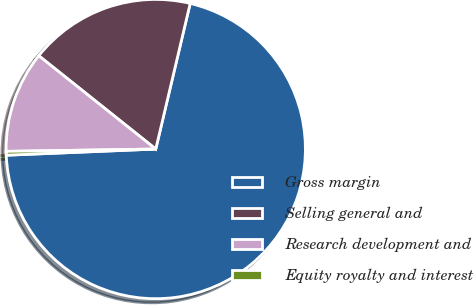<chart> <loc_0><loc_0><loc_500><loc_500><pie_chart><fcel>Gross margin<fcel>Selling general and<fcel>Research development and<fcel>Equity royalty and interest<nl><fcel>70.65%<fcel>17.98%<fcel>10.96%<fcel>0.41%<nl></chart> 